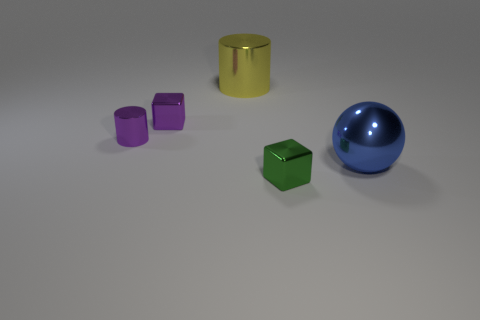There is a block to the right of the yellow cylinder; how many purple objects are behind it?
Keep it short and to the point. 2. What number of things are big gray rubber blocks or green things?
Keep it short and to the point. 1. Is the blue thing the same shape as the yellow object?
Make the answer very short. No. What is the small purple block made of?
Provide a succinct answer. Metal. What number of big objects are both behind the large blue metal sphere and in front of the yellow cylinder?
Make the answer very short. 0. Is the size of the purple metallic cube the same as the blue shiny object?
Provide a short and direct response. No. There is a cube right of the yellow cylinder; does it have the same size as the blue thing?
Ensure brevity in your answer.  No. What color is the cube on the left side of the small green metallic object?
Provide a succinct answer. Purple. How many yellow things are there?
Offer a terse response. 1. There is a blue object that is made of the same material as the big cylinder; what shape is it?
Your response must be concise. Sphere. 